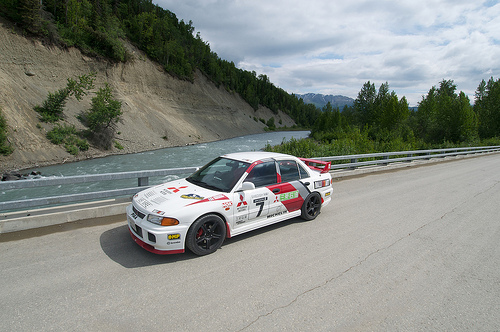<image>
Is there a racing car in front of the road? No. The racing car is not in front of the road. The spatial positioning shows a different relationship between these objects. 